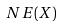Convert formula to latex. <formula><loc_0><loc_0><loc_500><loc_500>N E ( X )</formula> 